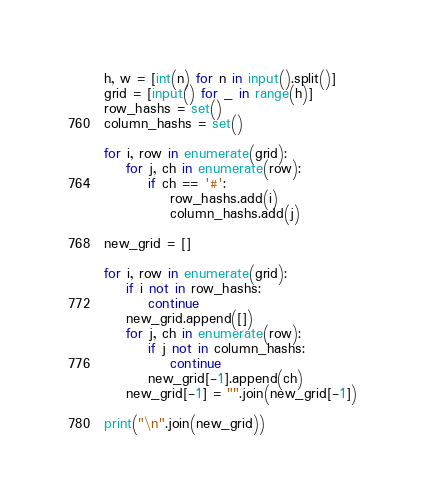Convert code to text. <code><loc_0><loc_0><loc_500><loc_500><_Python_>h, w = [int(n) for n in input().split()]
grid = [input() for _ in range(h)]
row_hashs = set()
column_hashs = set()

for i, row in enumerate(grid):
    for j, ch in enumerate(row):
        if ch == '#':
            row_hashs.add(i)
            column_hashs.add(j)

new_grid = []

for i, row in enumerate(grid):
    if i not in row_hashs:
        continue
    new_grid.append([])
    for j, ch in enumerate(row):
        if j not in column_hashs:
            continue
        new_grid[-1].append(ch)
    new_grid[-1] = "".join(new_grid[-1])

print("\n".join(new_grid))</code> 